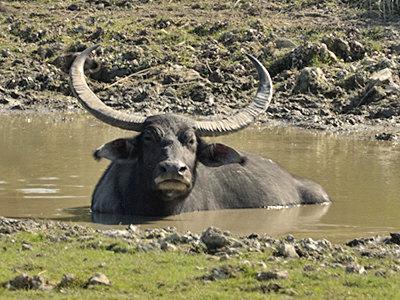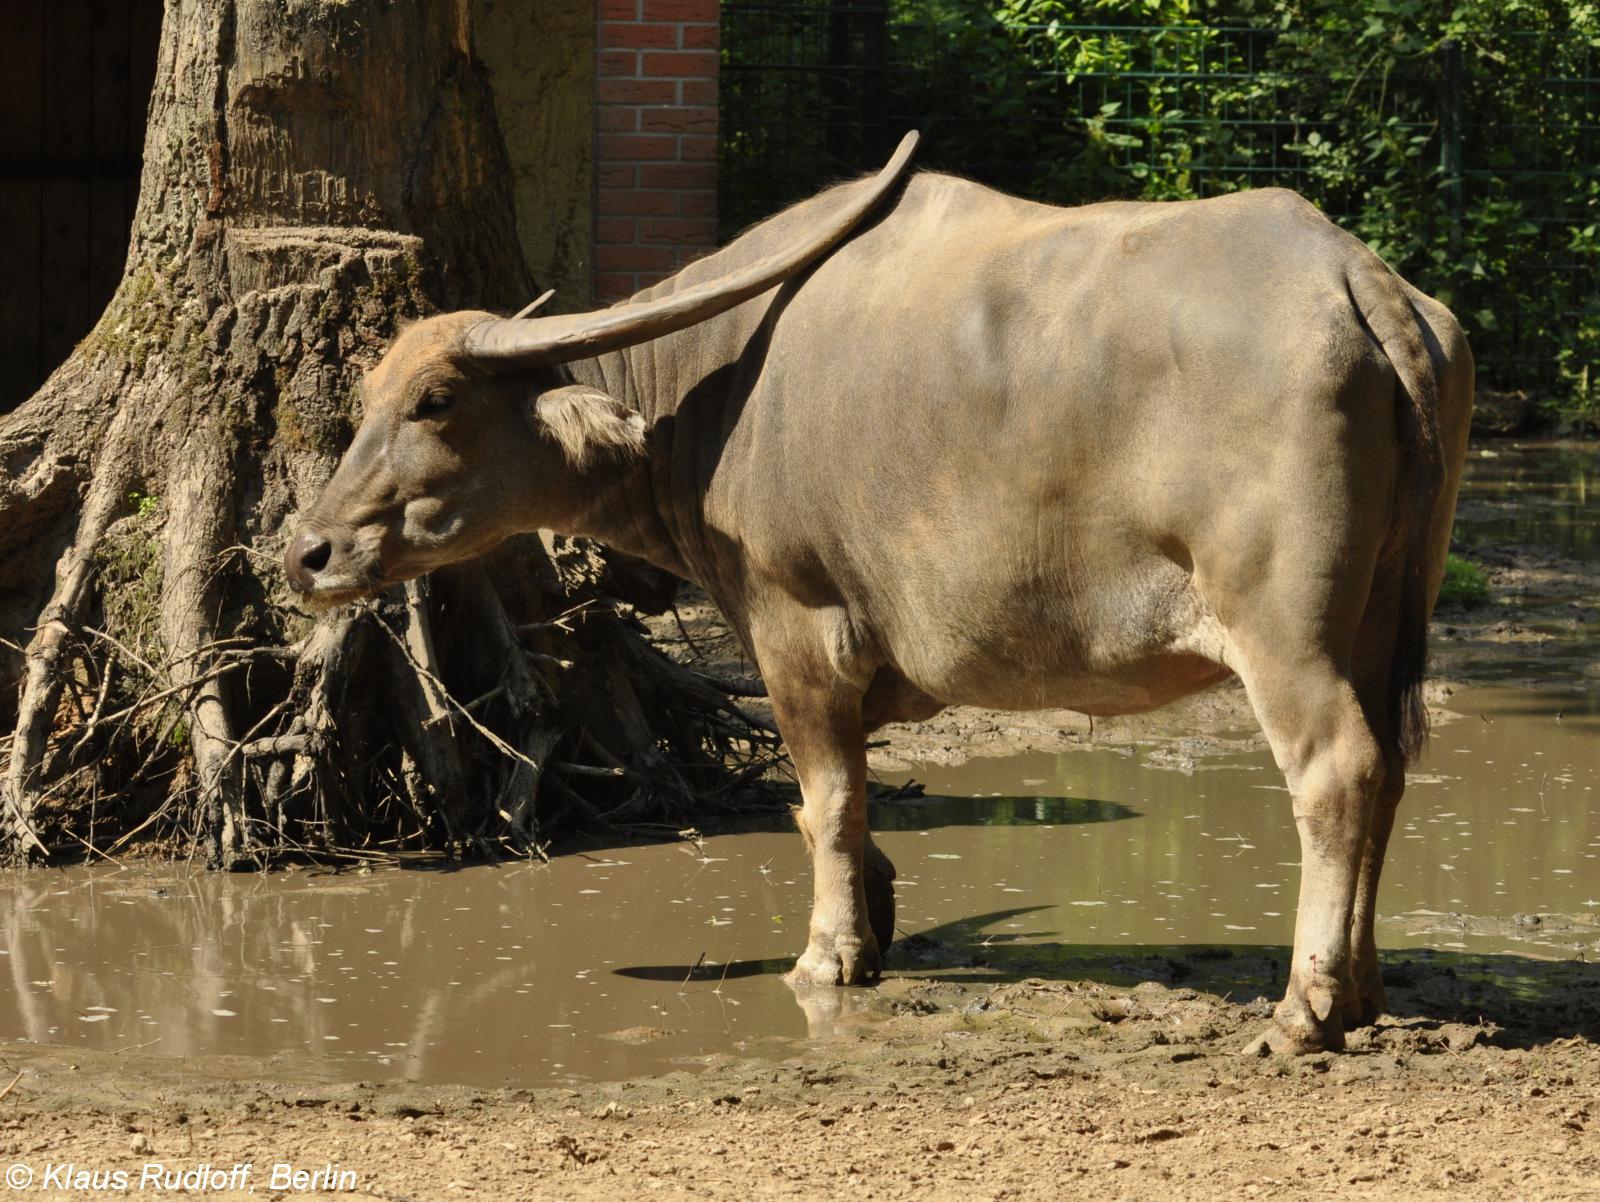The first image is the image on the left, the second image is the image on the right. Given the left and right images, does the statement "An image shows exactly one water buffalo standing on muddy, wet ground." hold true? Answer yes or no. Yes. The first image is the image on the left, the second image is the image on the right. Evaluate the accuracy of this statement regarding the images: "Two cows are standing in a watery area.". Is it true? Answer yes or no. Yes. 